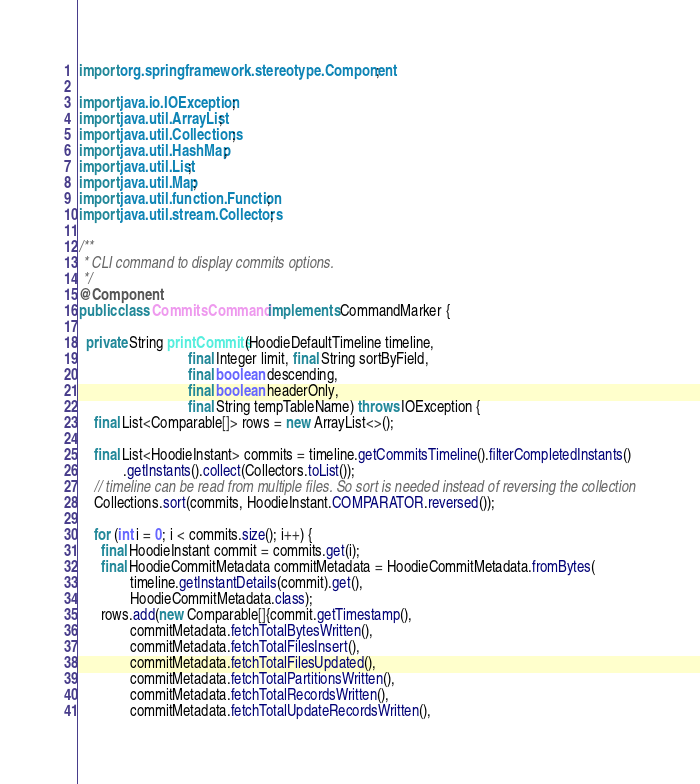Convert code to text. <code><loc_0><loc_0><loc_500><loc_500><_Java_>import org.springframework.stereotype.Component;

import java.io.IOException;
import java.util.ArrayList;
import java.util.Collections;
import java.util.HashMap;
import java.util.List;
import java.util.Map;
import java.util.function.Function;
import java.util.stream.Collectors;

/**
 * CLI command to display commits options.
 */
@Component
public class CommitsCommand implements CommandMarker {

  private String printCommits(HoodieDefaultTimeline timeline,
                              final Integer limit, final String sortByField,
                              final boolean descending,
                              final boolean headerOnly,
                              final String tempTableName) throws IOException {
    final List<Comparable[]> rows = new ArrayList<>();

    final List<HoodieInstant> commits = timeline.getCommitsTimeline().filterCompletedInstants()
            .getInstants().collect(Collectors.toList());
    // timeline can be read from multiple files. So sort is needed instead of reversing the collection
    Collections.sort(commits, HoodieInstant.COMPARATOR.reversed());

    for (int i = 0; i < commits.size(); i++) {
      final HoodieInstant commit = commits.get(i);
      final HoodieCommitMetadata commitMetadata = HoodieCommitMetadata.fromBytes(
              timeline.getInstantDetails(commit).get(),
              HoodieCommitMetadata.class);
      rows.add(new Comparable[]{commit.getTimestamp(),
              commitMetadata.fetchTotalBytesWritten(),
              commitMetadata.fetchTotalFilesInsert(),
              commitMetadata.fetchTotalFilesUpdated(),
              commitMetadata.fetchTotalPartitionsWritten(),
              commitMetadata.fetchTotalRecordsWritten(),
              commitMetadata.fetchTotalUpdateRecordsWritten(),</code> 